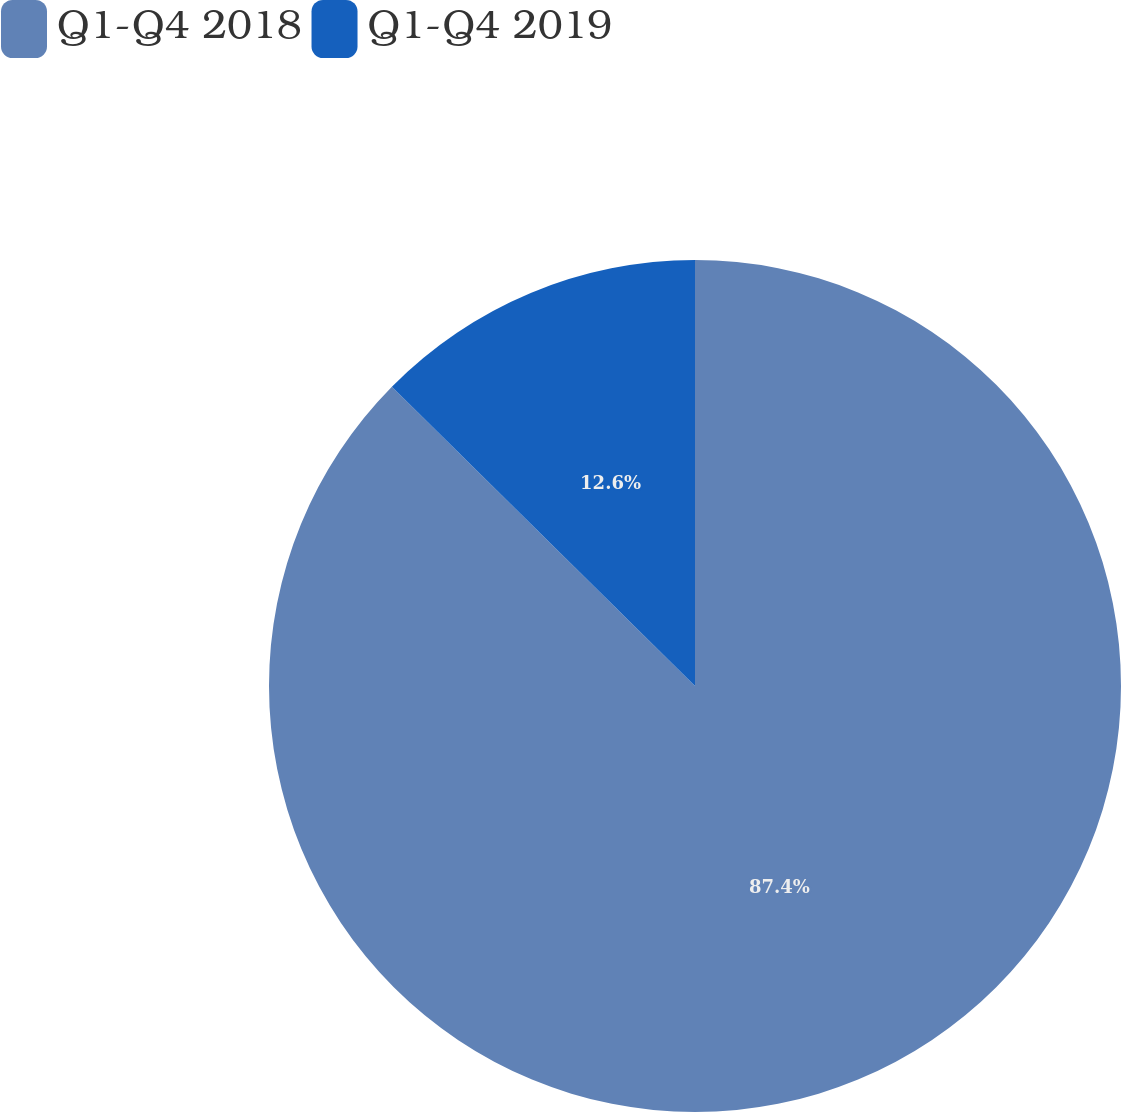Convert chart. <chart><loc_0><loc_0><loc_500><loc_500><pie_chart><fcel>Q1-Q4 2018<fcel>Q1-Q4 2019<nl><fcel>87.4%<fcel>12.6%<nl></chart> 